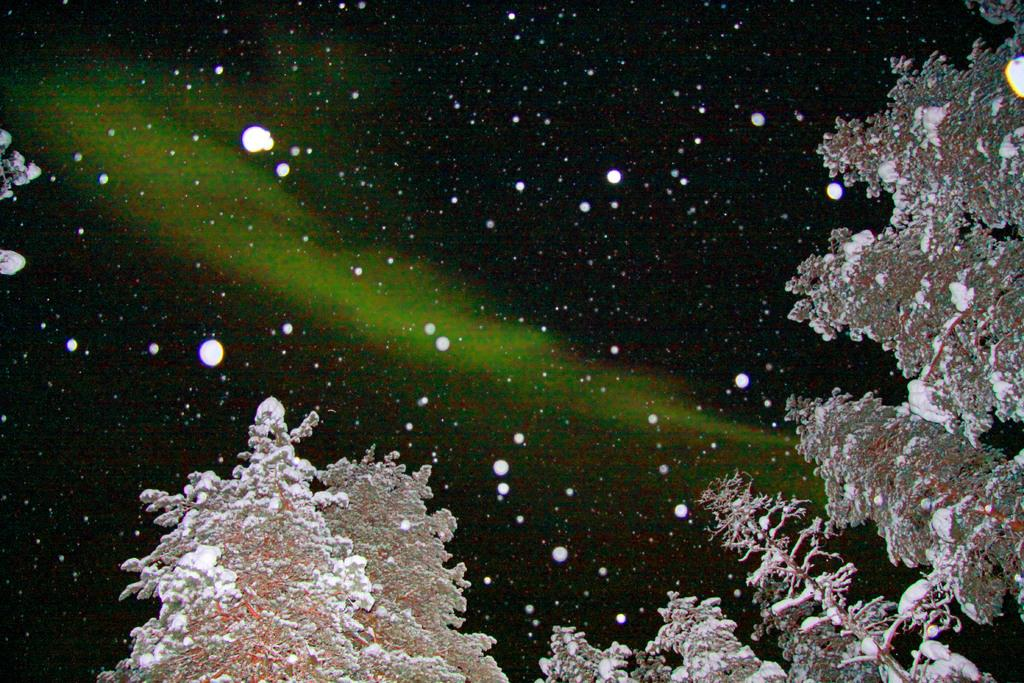What type of vegetation is present in the image? There are trees in the image. What is the condition of the trees in the image? The trees are covered with snow. What weather condition is occurring in the image? There is snowfall in the image. How many children can be seen playing in the snow in the image? There are no children present in the image; it only features trees covered in snow and snowfall. 